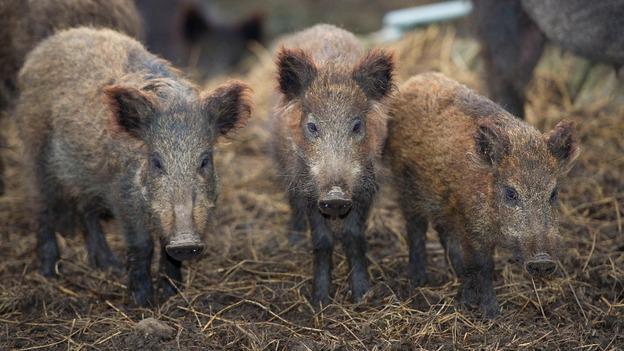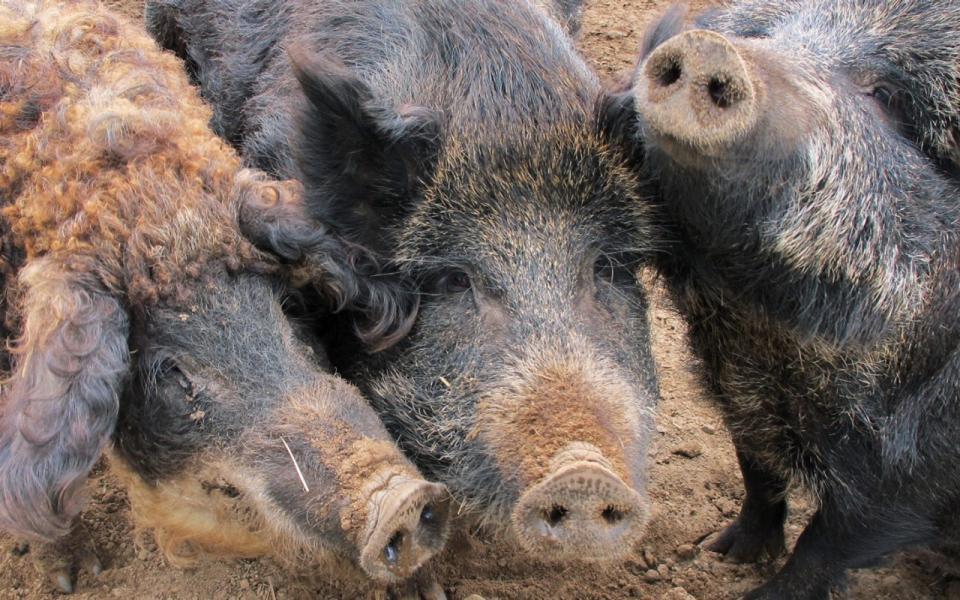The first image is the image on the left, the second image is the image on the right. Analyze the images presented: Is the assertion "There are exactly three animals in the image on the right." valid? Answer yes or no. Yes. The first image is the image on the left, the second image is the image on the right. Considering the images on both sides, is "Trees with green branches are behind a group of hogs in one image." valid? Answer yes or no. No. 